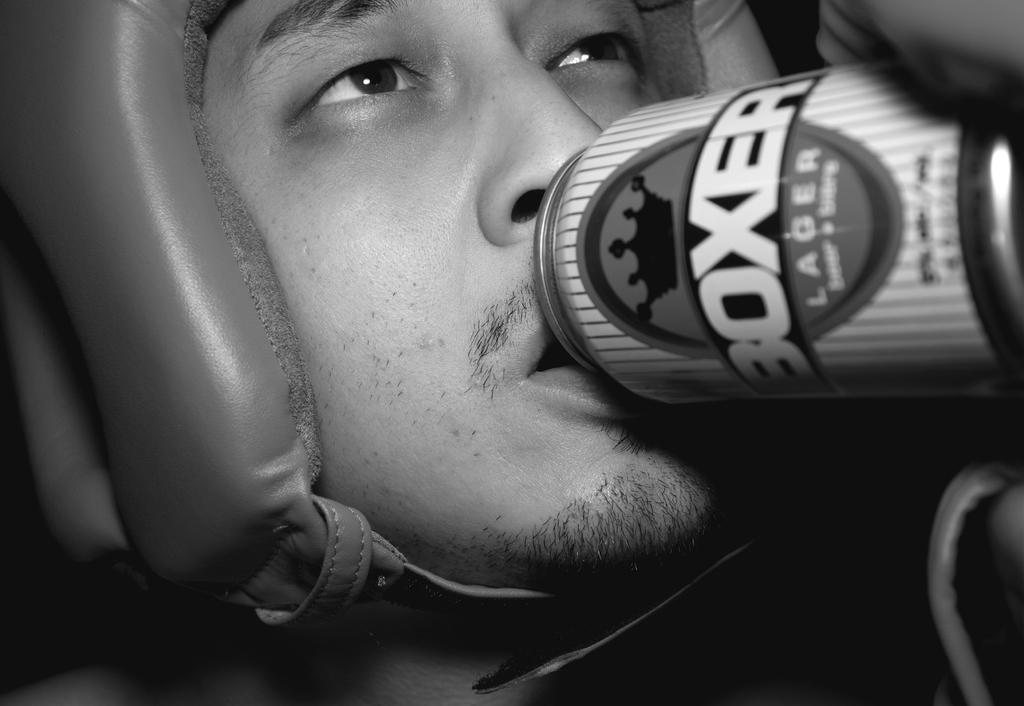Provide a one-sentence caption for the provided image. A person with a can of Boxer lager up to his mouth. 